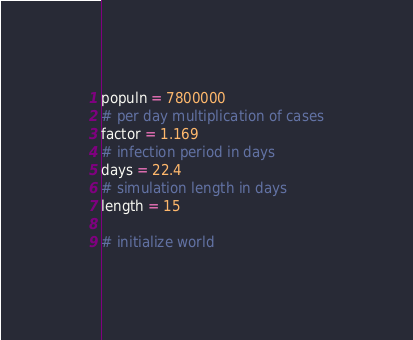<code> <loc_0><loc_0><loc_500><loc_500><_Python_>populn = 7800000
# per day multiplication of cases
factor = 1.169
# infection period in days
days = 22.4
# simulation length in days
length = 15

# initialize world</code> 